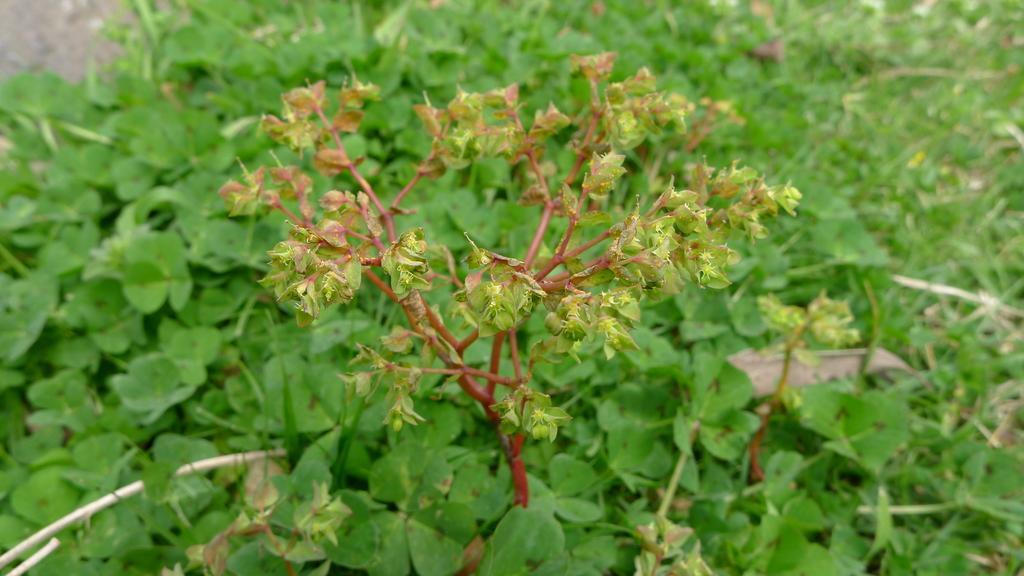In one or two sentences, can you explain what this image depicts? There is a plant in the center of the image and there is greenery in the background area. 